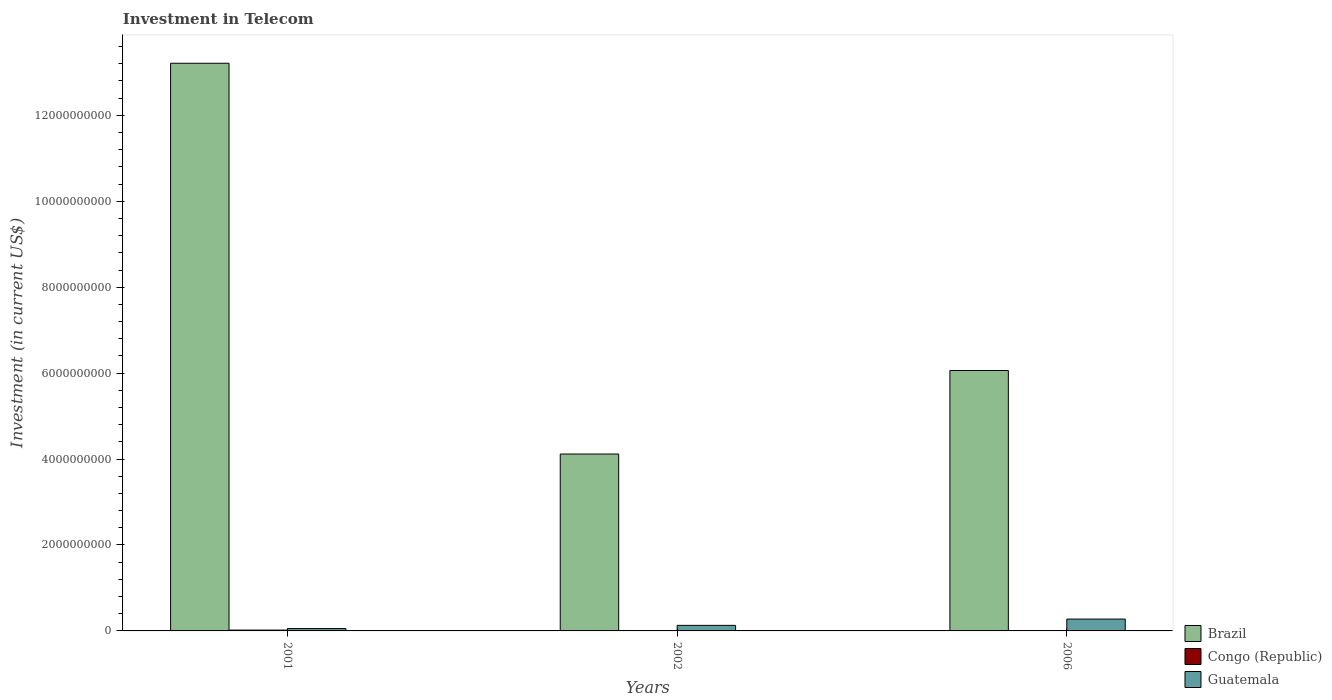How many groups of bars are there?
Offer a very short reply. 3. Are the number of bars per tick equal to the number of legend labels?
Your answer should be very brief. Yes. How many bars are there on the 2nd tick from the left?
Provide a short and direct response. 3. What is the label of the 3rd group of bars from the left?
Provide a succinct answer. 2006. In how many cases, is the number of bars for a given year not equal to the number of legend labels?
Keep it short and to the point. 0. What is the amount invested in telecom in Congo (Republic) in 2002?
Offer a very short reply. 7.00e+06. Across all years, what is the maximum amount invested in telecom in Congo (Republic)?
Provide a succinct answer. 1.96e+07. Across all years, what is the minimum amount invested in telecom in Congo (Republic)?
Make the answer very short. 7.00e+06. In which year was the amount invested in telecom in Guatemala minimum?
Ensure brevity in your answer.  2001. What is the total amount invested in telecom in Congo (Republic) in the graph?
Your response must be concise. 3.66e+07. What is the difference between the amount invested in telecom in Brazil in 2002 and that in 2006?
Your answer should be very brief. -1.94e+09. What is the difference between the amount invested in telecom in Congo (Republic) in 2001 and the amount invested in telecom in Brazil in 2006?
Offer a terse response. -6.04e+09. What is the average amount invested in telecom in Guatemala per year?
Offer a terse response. 1.53e+08. In the year 2001, what is the difference between the amount invested in telecom in Congo (Republic) and amount invested in telecom in Guatemala?
Provide a short and direct response. -3.51e+07. What is the ratio of the amount invested in telecom in Congo (Republic) in 2001 to that in 2006?
Provide a succinct answer. 1.96. What is the difference between the highest and the second highest amount invested in telecom in Guatemala?
Offer a terse response. 1.47e+08. What is the difference between the highest and the lowest amount invested in telecom in Guatemala?
Provide a succinct answer. 2.21e+08. What does the 2nd bar from the left in 2006 represents?
Your answer should be very brief. Congo (Republic). What does the 3rd bar from the right in 2002 represents?
Your answer should be compact. Brazil. Is it the case that in every year, the sum of the amount invested in telecom in Guatemala and amount invested in telecom in Congo (Republic) is greater than the amount invested in telecom in Brazil?
Make the answer very short. No. How many bars are there?
Ensure brevity in your answer.  9. Are all the bars in the graph horizontal?
Provide a succinct answer. No. What is the difference between two consecutive major ticks on the Y-axis?
Offer a very short reply. 2.00e+09. Does the graph contain grids?
Offer a terse response. No. Where does the legend appear in the graph?
Offer a very short reply. Bottom right. How many legend labels are there?
Offer a very short reply. 3. What is the title of the graph?
Provide a succinct answer. Investment in Telecom. What is the label or title of the Y-axis?
Give a very brief answer. Investment (in current US$). What is the Investment (in current US$) in Brazil in 2001?
Your response must be concise. 1.32e+1. What is the Investment (in current US$) of Congo (Republic) in 2001?
Provide a short and direct response. 1.96e+07. What is the Investment (in current US$) in Guatemala in 2001?
Provide a short and direct response. 5.47e+07. What is the Investment (in current US$) of Brazil in 2002?
Offer a terse response. 4.12e+09. What is the Investment (in current US$) of Congo (Republic) in 2002?
Provide a succinct answer. 7.00e+06. What is the Investment (in current US$) of Guatemala in 2002?
Provide a short and direct response. 1.29e+08. What is the Investment (in current US$) in Brazil in 2006?
Offer a terse response. 6.06e+09. What is the Investment (in current US$) in Guatemala in 2006?
Provide a succinct answer. 2.76e+08. Across all years, what is the maximum Investment (in current US$) of Brazil?
Your answer should be compact. 1.32e+1. Across all years, what is the maximum Investment (in current US$) of Congo (Republic)?
Give a very brief answer. 1.96e+07. Across all years, what is the maximum Investment (in current US$) of Guatemala?
Ensure brevity in your answer.  2.76e+08. Across all years, what is the minimum Investment (in current US$) in Brazil?
Give a very brief answer. 4.12e+09. Across all years, what is the minimum Investment (in current US$) in Guatemala?
Your answer should be very brief. 5.47e+07. What is the total Investment (in current US$) in Brazil in the graph?
Offer a very short reply. 2.34e+1. What is the total Investment (in current US$) in Congo (Republic) in the graph?
Your answer should be very brief. 3.66e+07. What is the total Investment (in current US$) in Guatemala in the graph?
Offer a very short reply. 4.60e+08. What is the difference between the Investment (in current US$) in Brazil in 2001 and that in 2002?
Keep it short and to the point. 9.10e+09. What is the difference between the Investment (in current US$) in Congo (Republic) in 2001 and that in 2002?
Offer a very short reply. 1.26e+07. What is the difference between the Investment (in current US$) of Guatemala in 2001 and that in 2002?
Keep it short and to the point. -7.47e+07. What is the difference between the Investment (in current US$) in Brazil in 2001 and that in 2006?
Your response must be concise. 7.15e+09. What is the difference between the Investment (in current US$) of Congo (Republic) in 2001 and that in 2006?
Make the answer very short. 9.60e+06. What is the difference between the Investment (in current US$) of Guatemala in 2001 and that in 2006?
Keep it short and to the point. -2.21e+08. What is the difference between the Investment (in current US$) of Brazil in 2002 and that in 2006?
Give a very brief answer. -1.94e+09. What is the difference between the Investment (in current US$) of Guatemala in 2002 and that in 2006?
Provide a succinct answer. -1.47e+08. What is the difference between the Investment (in current US$) in Brazil in 2001 and the Investment (in current US$) in Congo (Republic) in 2002?
Provide a succinct answer. 1.32e+1. What is the difference between the Investment (in current US$) of Brazil in 2001 and the Investment (in current US$) of Guatemala in 2002?
Your response must be concise. 1.31e+1. What is the difference between the Investment (in current US$) of Congo (Republic) in 2001 and the Investment (in current US$) of Guatemala in 2002?
Provide a succinct answer. -1.10e+08. What is the difference between the Investment (in current US$) in Brazil in 2001 and the Investment (in current US$) in Congo (Republic) in 2006?
Provide a succinct answer. 1.32e+1. What is the difference between the Investment (in current US$) in Brazil in 2001 and the Investment (in current US$) in Guatemala in 2006?
Ensure brevity in your answer.  1.29e+1. What is the difference between the Investment (in current US$) of Congo (Republic) in 2001 and the Investment (in current US$) of Guatemala in 2006?
Your response must be concise. -2.56e+08. What is the difference between the Investment (in current US$) in Brazil in 2002 and the Investment (in current US$) in Congo (Republic) in 2006?
Provide a succinct answer. 4.11e+09. What is the difference between the Investment (in current US$) in Brazil in 2002 and the Investment (in current US$) in Guatemala in 2006?
Provide a succinct answer. 3.84e+09. What is the difference between the Investment (in current US$) of Congo (Republic) in 2002 and the Investment (in current US$) of Guatemala in 2006?
Ensure brevity in your answer.  -2.69e+08. What is the average Investment (in current US$) of Brazil per year?
Keep it short and to the point. 7.80e+09. What is the average Investment (in current US$) in Congo (Republic) per year?
Make the answer very short. 1.22e+07. What is the average Investment (in current US$) in Guatemala per year?
Give a very brief answer. 1.53e+08. In the year 2001, what is the difference between the Investment (in current US$) in Brazil and Investment (in current US$) in Congo (Republic)?
Your response must be concise. 1.32e+1. In the year 2001, what is the difference between the Investment (in current US$) of Brazil and Investment (in current US$) of Guatemala?
Offer a terse response. 1.32e+1. In the year 2001, what is the difference between the Investment (in current US$) in Congo (Republic) and Investment (in current US$) in Guatemala?
Offer a terse response. -3.51e+07. In the year 2002, what is the difference between the Investment (in current US$) of Brazil and Investment (in current US$) of Congo (Republic)?
Offer a terse response. 4.11e+09. In the year 2002, what is the difference between the Investment (in current US$) of Brazil and Investment (in current US$) of Guatemala?
Offer a terse response. 3.99e+09. In the year 2002, what is the difference between the Investment (in current US$) of Congo (Republic) and Investment (in current US$) of Guatemala?
Provide a succinct answer. -1.22e+08. In the year 2006, what is the difference between the Investment (in current US$) in Brazil and Investment (in current US$) in Congo (Republic)?
Your answer should be compact. 6.05e+09. In the year 2006, what is the difference between the Investment (in current US$) of Brazil and Investment (in current US$) of Guatemala?
Offer a terse response. 5.79e+09. In the year 2006, what is the difference between the Investment (in current US$) in Congo (Republic) and Investment (in current US$) in Guatemala?
Offer a terse response. -2.66e+08. What is the ratio of the Investment (in current US$) of Brazil in 2001 to that in 2002?
Your answer should be very brief. 3.21. What is the ratio of the Investment (in current US$) of Guatemala in 2001 to that in 2002?
Make the answer very short. 0.42. What is the ratio of the Investment (in current US$) of Brazil in 2001 to that in 2006?
Offer a terse response. 2.18. What is the ratio of the Investment (in current US$) of Congo (Republic) in 2001 to that in 2006?
Keep it short and to the point. 1.96. What is the ratio of the Investment (in current US$) in Guatemala in 2001 to that in 2006?
Offer a terse response. 0.2. What is the ratio of the Investment (in current US$) of Brazil in 2002 to that in 2006?
Give a very brief answer. 0.68. What is the ratio of the Investment (in current US$) in Congo (Republic) in 2002 to that in 2006?
Your answer should be very brief. 0.7. What is the ratio of the Investment (in current US$) of Guatemala in 2002 to that in 2006?
Offer a very short reply. 0.47. What is the difference between the highest and the second highest Investment (in current US$) of Brazil?
Ensure brevity in your answer.  7.15e+09. What is the difference between the highest and the second highest Investment (in current US$) of Congo (Republic)?
Your response must be concise. 9.60e+06. What is the difference between the highest and the second highest Investment (in current US$) of Guatemala?
Keep it short and to the point. 1.47e+08. What is the difference between the highest and the lowest Investment (in current US$) of Brazil?
Keep it short and to the point. 9.10e+09. What is the difference between the highest and the lowest Investment (in current US$) in Congo (Republic)?
Give a very brief answer. 1.26e+07. What is the difference between the highest and the lowest Investment (in current US$) of Guatemala?
Offer a very short reply. 2.21e+08. 